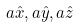Convert formula to latex. <formula><loc_0><loc_0><loc_500><loc_500>a \hat { x } , a \hat { y } , a \hat { z }</formula> 